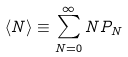Convert formula to latex. <formula><loc_0><loc_0><loc_500><loc_500>\langle N \rangle \equiv \sum _ { N = 0 } ^ { \infty } N P _ { N }</formula> 